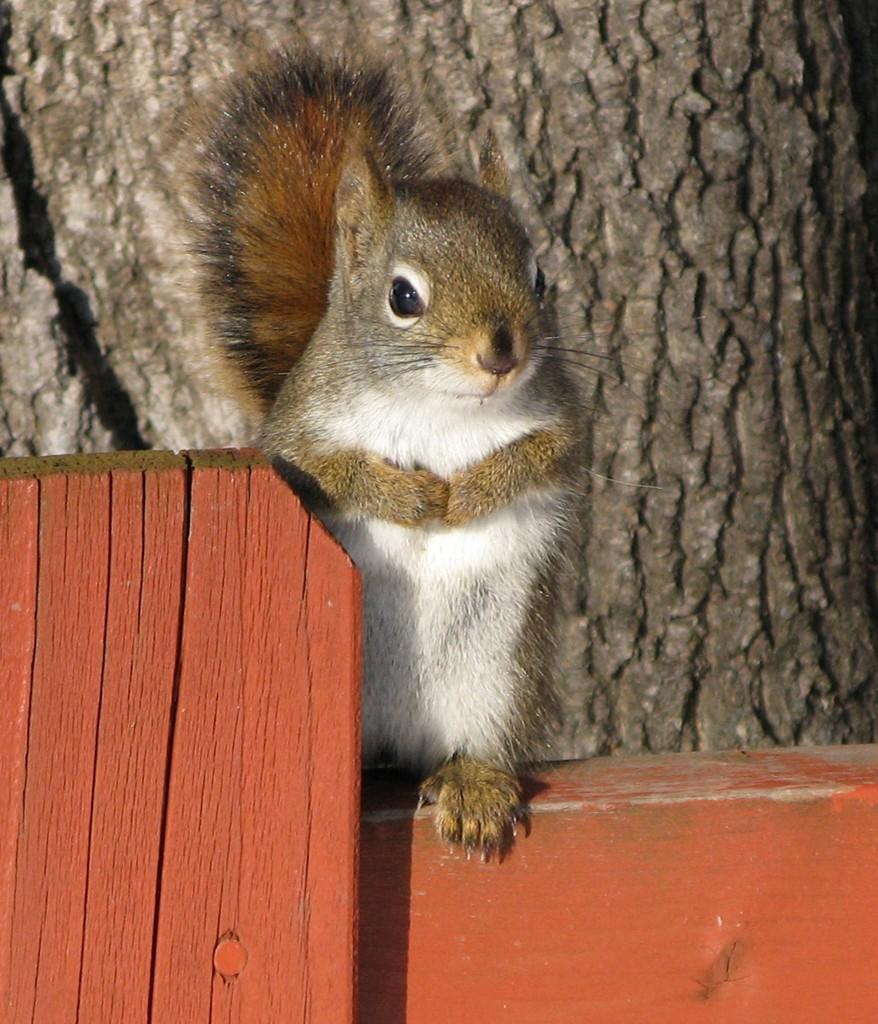Can you describe this image briefly? In this image I can see squirrel in the middle of the image. In the background it looks like the trunk of a tree. 